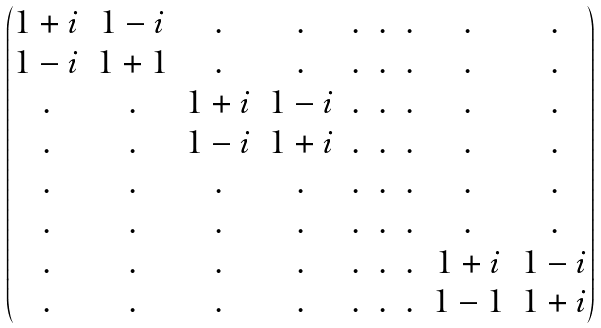<formula> <loc_0><loc_0><loc_500><loc_500>\begin{pmatrix} 1 + i & 1 - i & . & . & . & . & . & . & . \\ 1 - i & 1 + 1 & . & . & . & . & . & . & . \\ . & . & 1 + i & 1 - i & . & . & . & . & . \\ . & . & 1 - i & 1 + i & . & . & . & . & . \\ . & . & . & . & . & . & . & . & . \\ . & . & . & . & . & . & . & . & . \\ . & . & . & . & . & . & . & 1 + i & 1 - i \\ . & . & . & . & . & . & . & 1 - 1 & 1 + i \\ \end{pmatrix}</formula> 